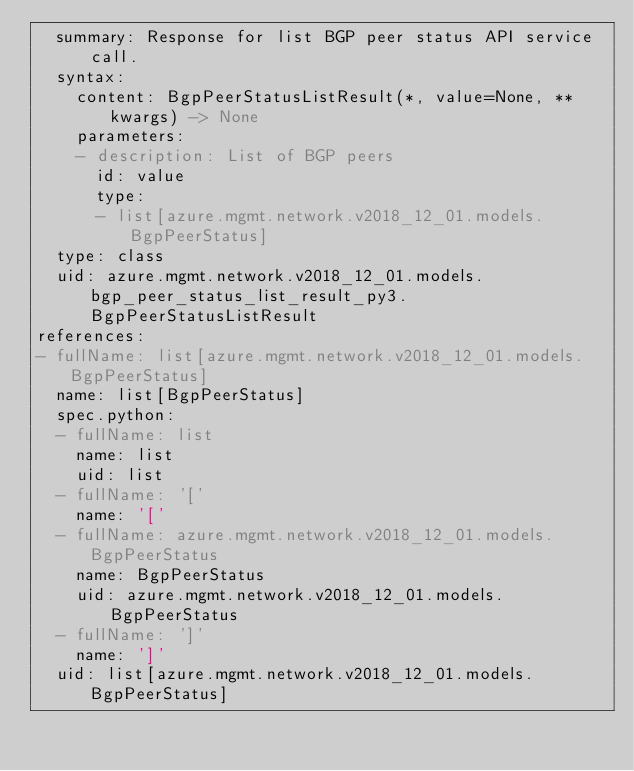Convert code to text. <code><loc_0><loc_0><loc_500><loc_500><_YAML_>  summary: Response for list BGP peer status API service call.
  syntax:
    content: BgpPeerStatusListResult(*, value=None, **kwargs) -> None
    parameters:
    - description: List of BGP peers
      id: value
      type:
      - list[azure.mgmt.network.v2018_12_01.models.BgpPeerStatus]
  type: class
  uid: azure.mgmt.network.v2018_12_01.models.bgp_peer_status_list_result_py3.BgpPeerStatusListResult
references:
- fullName: list[azure.mgmt.network.v2018_12_01.models.BgpPeerStatus]
  name: list[BgpPeerStatus]
  spec.python:
  - fullName: list
    name: list
    uid: list
  - fullName: '['
    name: '['
  - fullName: azure.mgmt.network.v2018_12_01.models.BgpPeerStatus
    name: BgpPeerStatus
    uid: azure.mgmt.network.v2018_12_01.models.BgpPeerStatus
  - fullName: ']'
    name: ']'
  uid: list[azure.mgmt.network.v2018_12_01.models.BgpPeerStatus]
</code> 